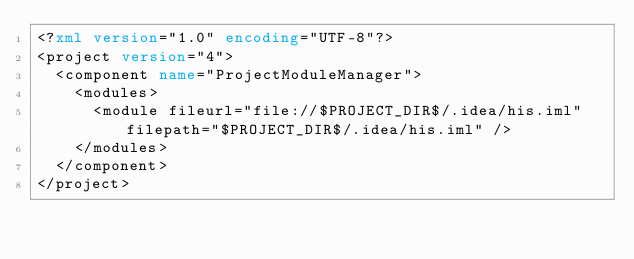<code> <loc_0><loc_0><loc_500><loc_500><_XML_><?xml version="1.0" encoding="UTF-8"?>
<project version="4">
  <component name="ProjectModuleManager">
    <modules>
      <module fileurl="file://$PROJECT_DIR$/.idea/his.iml" filepath="$PROJECT_DIR$/.idea/his.iml" />
    </modules>
  </component>
</project></code> 